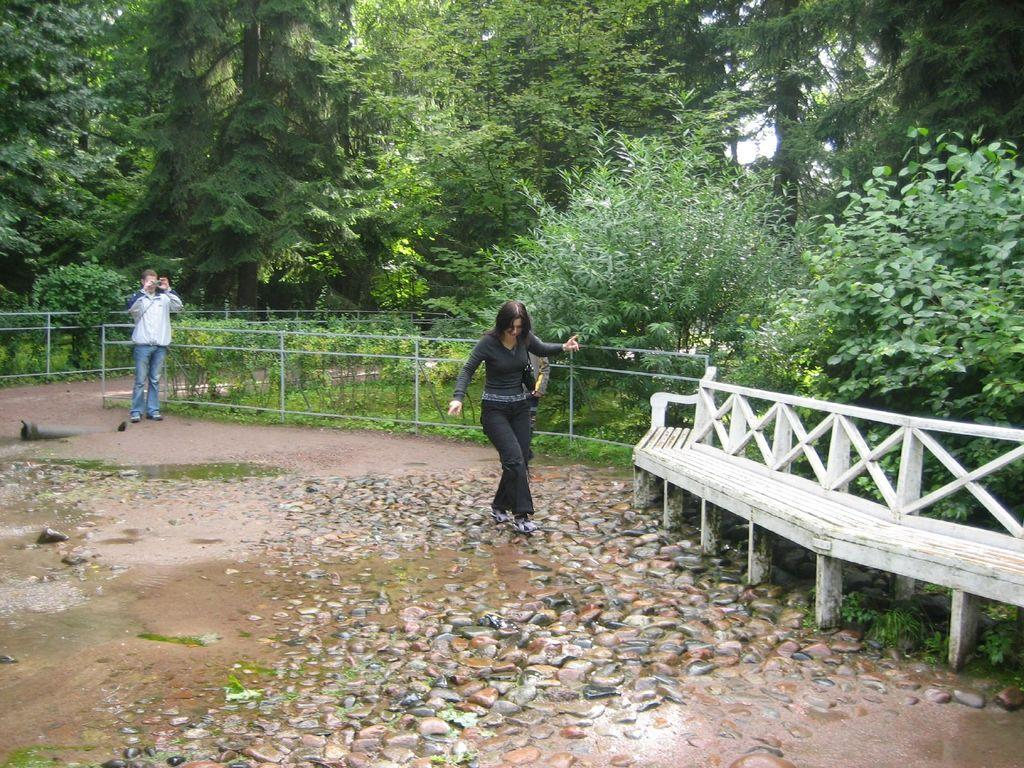How many people are present in the image? There is a man and a woman in the image, making a total of two people. What type of natural elements can be seen in the image? Stones, plants, trees, and groundwater are visible in the image. What type of seating is available in the image? There is a bench in the image. What type of barrier is present in the image? There is a fence in the image. What is visible in the background of the image? The sky is visible in the background of the image. What type of brush can be seen in the image? There is no brush present in the image. What effect does the room have on the people in the image? There is no room present in the image, so it cannot have any effect on the people. 